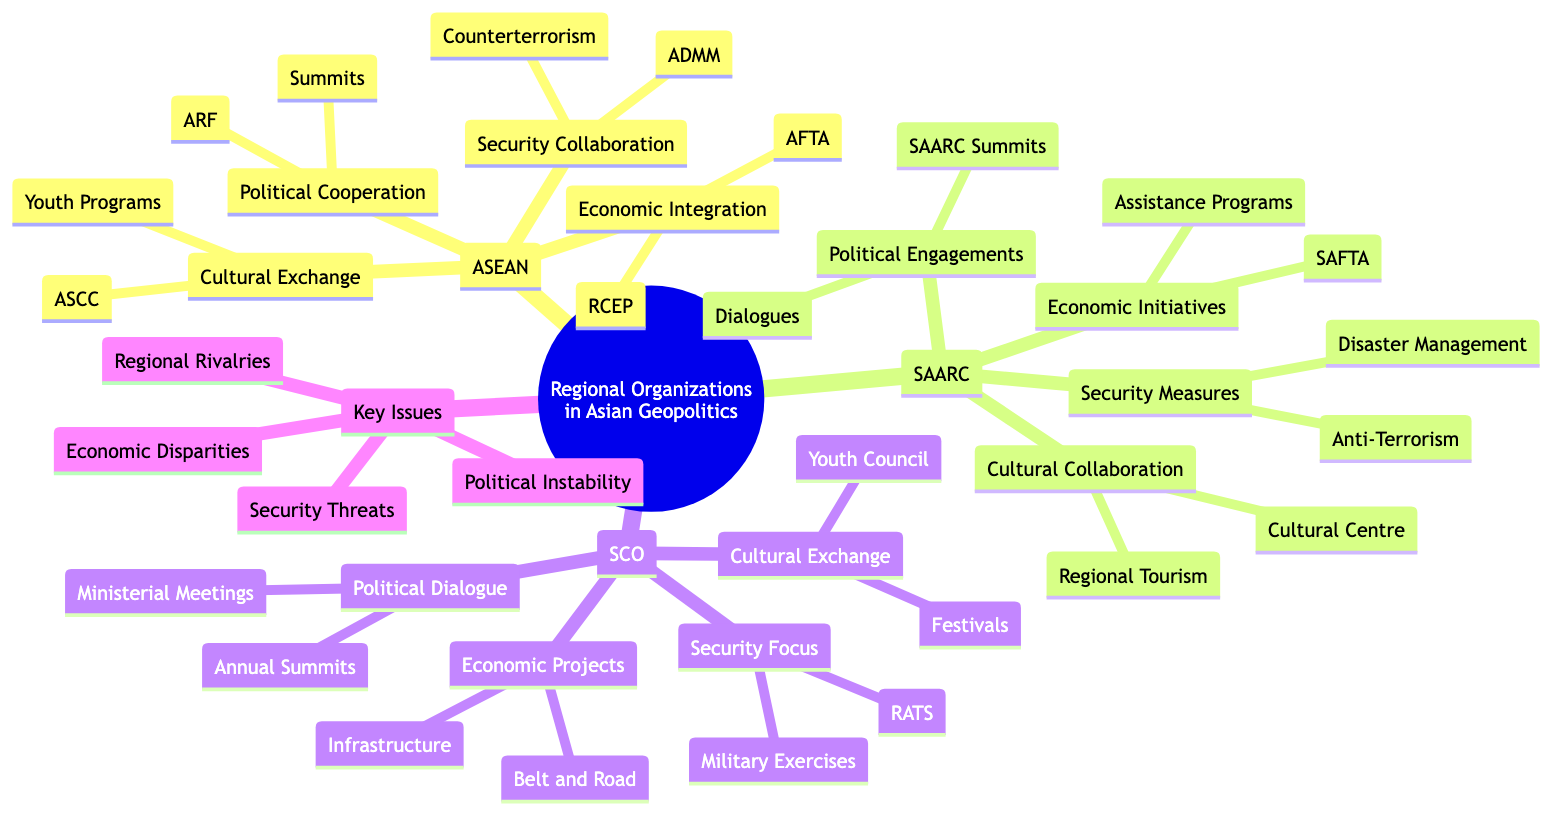What are the economic initiatives of SAARC? The economic initiatives of SAARC are listed under the SAARC section in the mind map. They include "South Asian Free Trade Area (SAFTA)" and "Economic Assistance Programs."
Answer: South Asian Free Trade Area (SAFTA), Economic Assistance Programs How many main regional organizations are depicted in the diagram? The diagram lists three main regional organizations: ASEAN, SAARC, and the Shanghai Cooperation Organization (SCO). Counting these gives us a total of three organizations.
Answer: 3 What type of collaborations are emphasized in the ASEAN section? In the ASEAN section, various types of collaborations are mentioned: Economic Integration, Political Cooperation, Security Collaboration, and Cultural and Social Exchange.
Answer: Economic Integration, Political Cooperation, Security Collaboration, Cultural and Social Exchange What is one key issue faced by regional organizations according to the diagram? The diagram specifies a section labeled "Key Issues and Challenges," under which several issues are identified. One example from this list is "Political Instability."
Answer: Political Instability What type of exchange is emphasized in the SCO section? The SCO section highlights "Cultural and Academic Exchange" as one of its key areas. It includes elements like the "SCO Youth Council" and "Cultural Festivals."
Answer: Cultural and Academic Exchange How many security collaboration efforts are mentioned for ASEAN? In the ASEAN section, two specific security collaboration efforts are listed: "ASEAN Defence Ministers Meeting (ADMM)" and "Counterterrorism Efforts." This means there are two efforts detailed.
Answer: 2 Which regional organization includes a platform for disaster management? The SAARC organization includes "Disaster Management Framework" as part of its security measures. This indicates its focus on addressing disasters.
Answer: SAARC What is the relationship between ASEAN and RCEP? RCEP is part of ASEAN's "Economic Integration" category, indicating that RCEP is a specific initiative aimed at enhancing regional economic cooperation under the ASEAN framework.
Answer: RCEP is an initiative under Economic Integration What is the role of the Regional Anti-Terrorist Structure (RATS) in the SCO? The Regional Anti-Terrorist Structure (RATS) is highlighted under the "Security Focus" in the SCO section, emphasizing its purpose in countering terrorism within the region.
Answer: Countering terrorism 